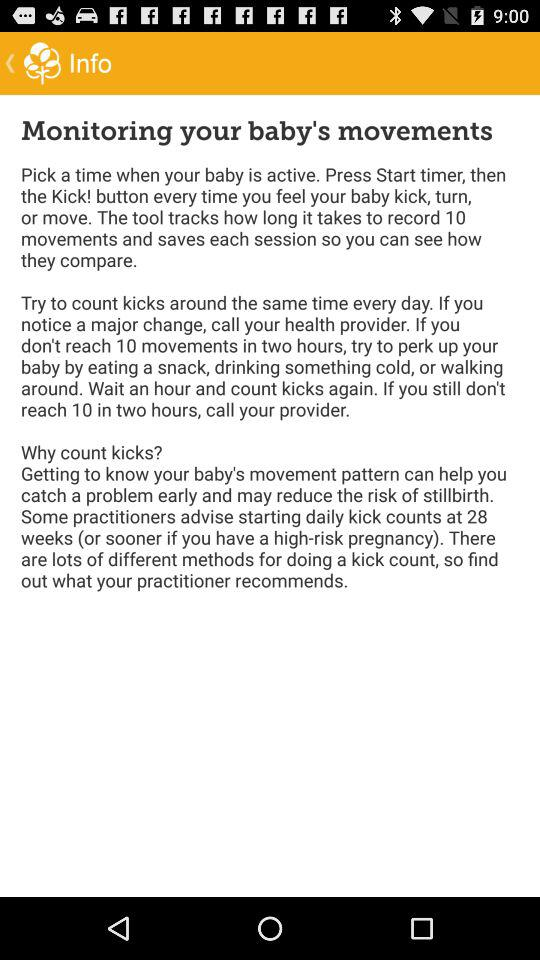In what week is starting the daily kick count advised? Starting the daily kick count is advised at 28 weeks. 